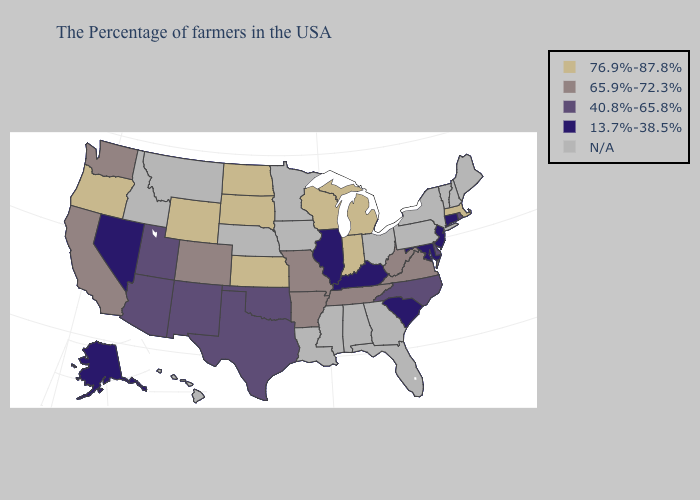Among the states that border Kentucky , does Missouri have the lowest value?
Be succinct. No. Does Missouri have the highest value in the MidWest?
Answer briefly. No. Name the states that have a value in the range 13.7%-38.5%?
Short answer required. Connecticut, New Jersey, Maryland, South Carolina, Kentucky, Illinois, Nevada, Alaska. What is the lowest value in the USA?
Be succinct. 13.7%-38.5%. Which states have the lowest value in the Northeast?
Be succinct. Connecticut, New Jersey. Name the states that have a value in the range 13.7%-38.5%?
Write a very short answer. Connecticut, New Jersey, Maryland, South Carolina, Kentucky, Illinois, Nevada, Alaska. What is the highest value in the West ?
Answer briefly. 76.9%-87.8%. How many symbols are there in the legend?
Give a very brief answer. 5. Name the states that have a value in the range 65.9%-72.3%?
Give a very brief answer. Virginia, West Virginia, Tennessee, Missouri, Arkansas, Colorado, California, Washington. Among the states that border Iowa , which have the highest value?
Write a very short answer. Wisconsin, South Dakota. Name the states that have a value in the range 40.8%-65.8%?
Answer briefly. Rhode Island, Delaware, North Carolina, Oklahoma, Texas, New Mexico, Utah, Arizona. Which states have the highest value in the USA?
Write a very short answer. Massachusetts, Michigan, Indiana, Wisconsin, Kansas, South Dakota, North Dakota, Wyoming, Oregon. What is the lowest value in the USA?
Be succinct. 13.7%-38.5%. 